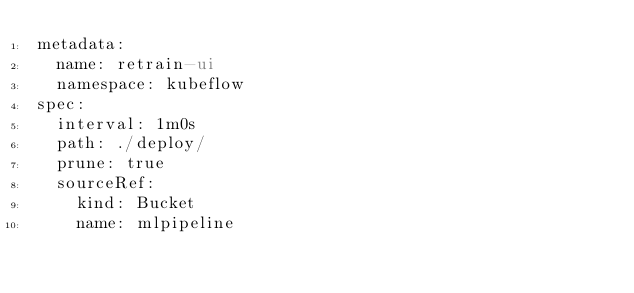Convert code to text. <code><loc_0><loc_0><loc_500><loc_500><_YAML_>metadata:
  name: retrain-ui
  namespace: kubeflow
spec:
  interval: 1m0s
  path: ./deploy/
  prune: true
  sourceRef:
    kind: Bucket
    name: mlpipeline</code> 